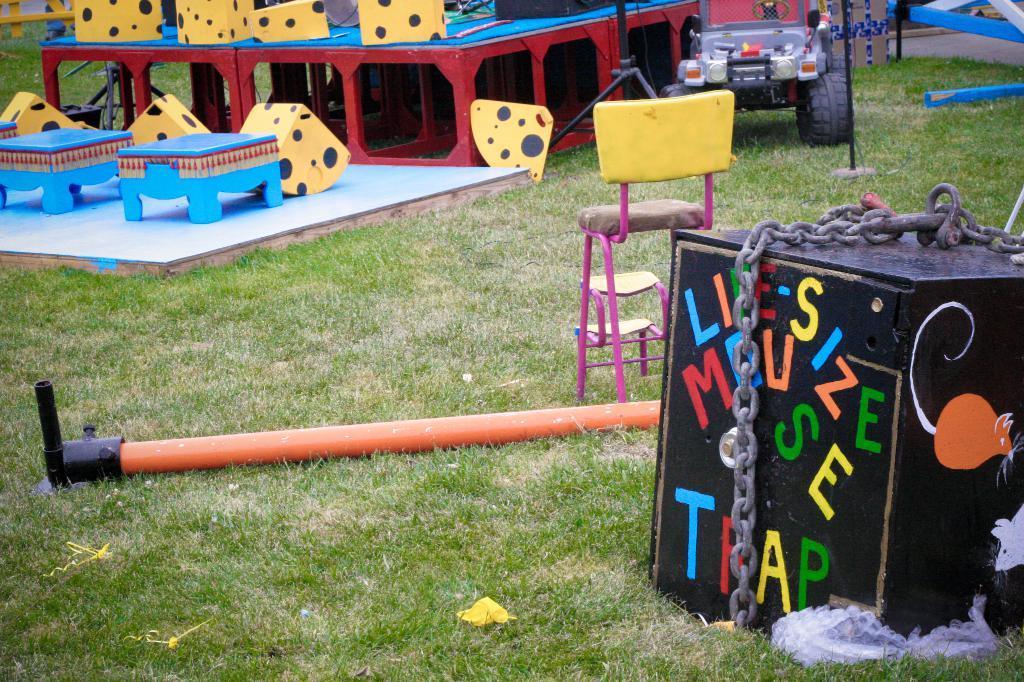Describe this image in one or two sentences. This picture looks like a kids play zone and i can see a small jeep and chair and grass on the ground and a box with chain to it and a metal pole on the ground. 